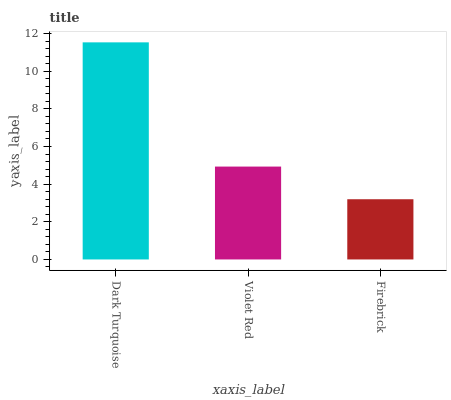Is Firebrick the minimum?
Answer yes or no. Yes. Is Dark Turquoise the maximum?
Answer yes or no. Yes. Is Violet Red the minimum?
Answer yes or no. No. Is Violet Red the maximum?
Answer yes or no. No. Is Dark Turquoise greater than Violet Red?
Answer yes or no. Yes. Is Violet Red less than Dark Turquoise?
Answer yes or no. Yes. Is Violet Red greater than Dark Turquoise?
Answer yes or no. No. Is Dark Turquoise less than Violet Red?
Answer yes or no. No. Is Violet Red the high median?
Answer yes or no. Yes. Is Violet Red the low median?
Answer yes or no. Yes. Is Firebrick the high median?
Answer yes or no. No. Is Firebrick the low median?
Answer yes or no. No. 